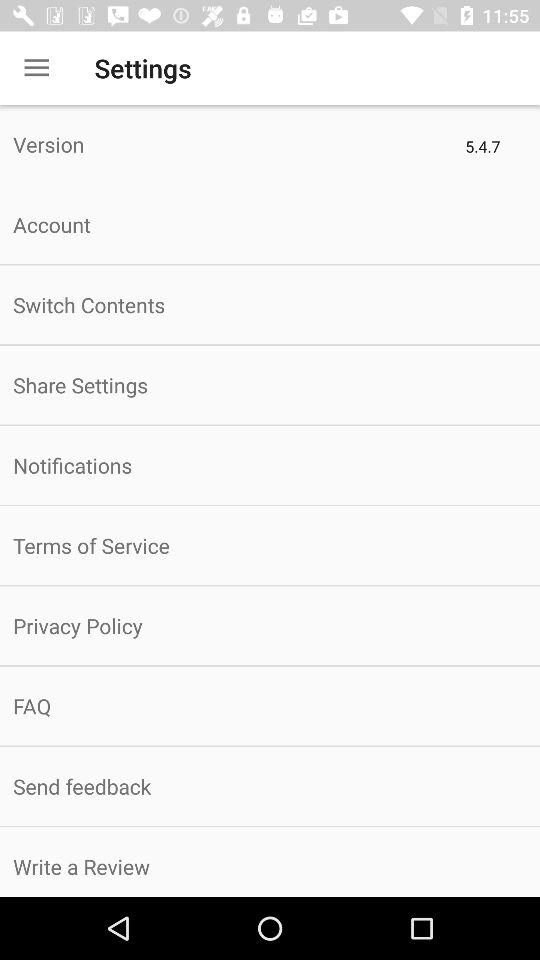What is the version? The version is 5.4.7. 